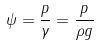Convert formula to latex. <formula><loc_0><loc_0><loc_500><loc_500>\psi = \frac { p } { \gamma } = \frac { p } { \rho g }</formula> 